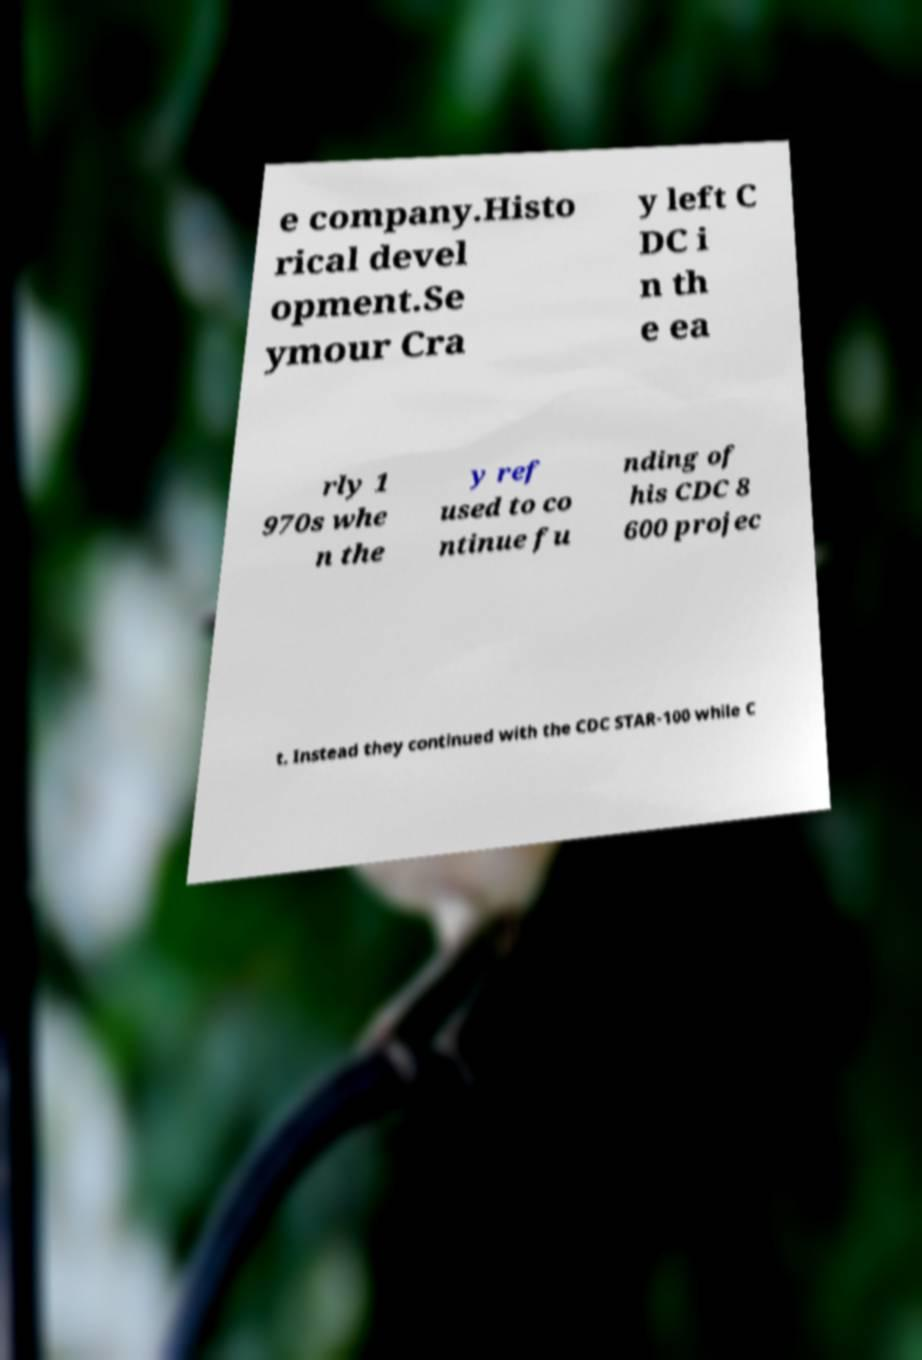There's text embedded in this image that I need extracted. Can you transcribe it verbatim? e company.Histo rical devel opment.Se ymour Cra y left C DC i n th e ea rly 1 970s whe n the y ref used to co ntinue fu nding of his CDC 8 600 projec t. Instead they continued with the CDC STAR-100 while C 